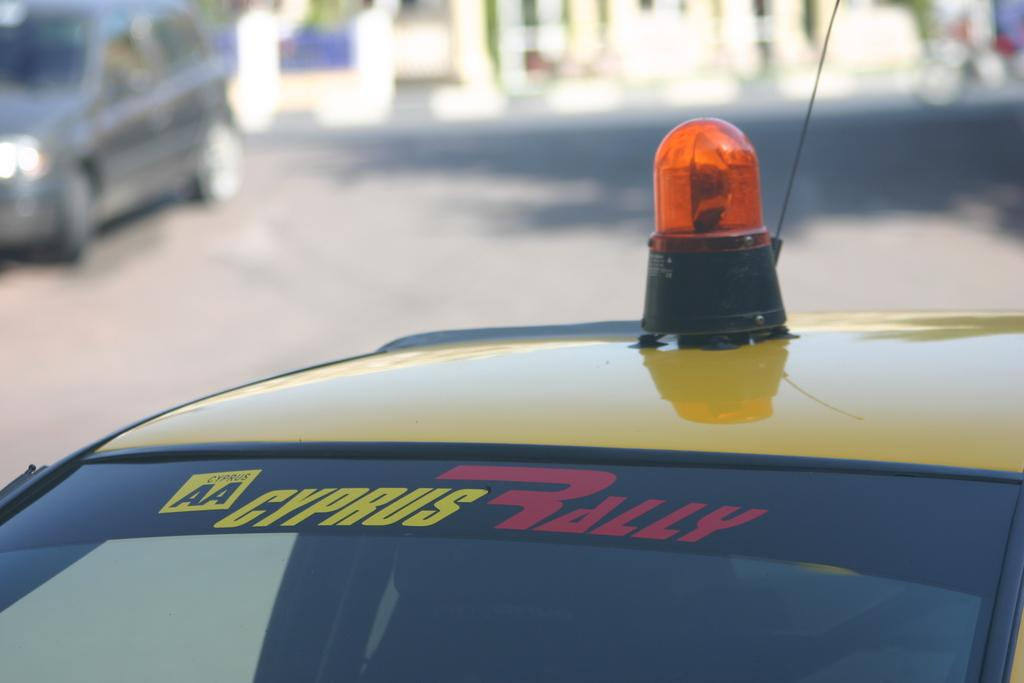Provide a one-sentence caption for the provided image. a Cyprus Rally name on a vehicile of sorts. 